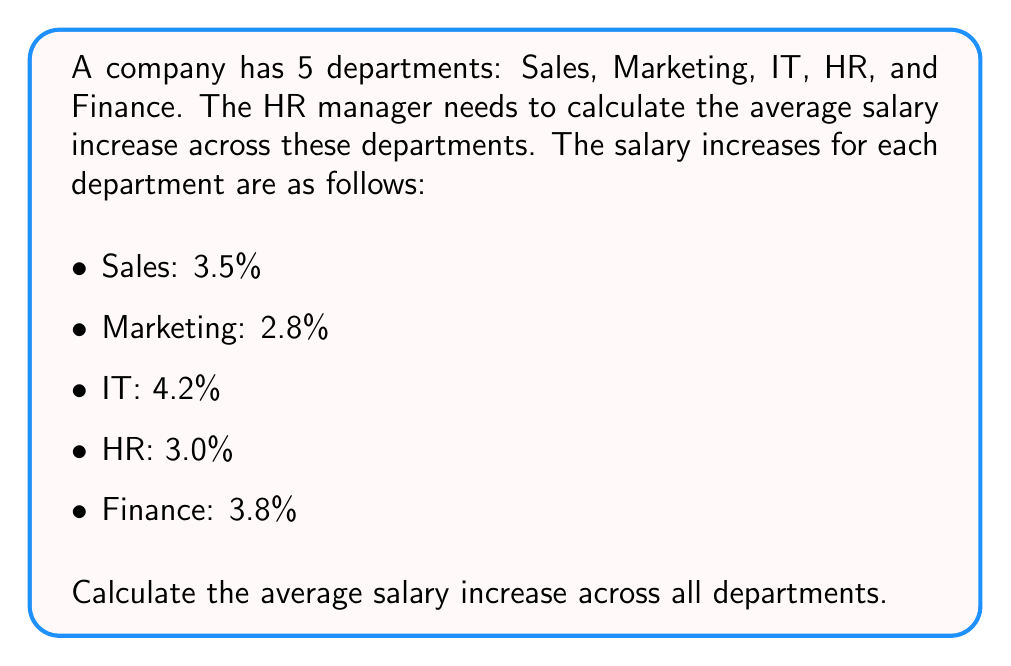Give your solution to this math problem. To calculate the average salary increase across all departments, we need to follow these steps:

1. Sum up all the salary increases:
   $$3.5\% + 2.8\% + 4.2\% + 3.0\% + 3.8\% = 17.3\%$$

2. Count the total number of departments:
   There are 5 departments in total.

3. Calculate the average by dividing the sum by the number of departments:
   $$\text{Average} = \frac{\text{Sum of salary increases}}{\text{Number of departments}}$$
   $$\text{Average} = \frac{17.3\%}{5} = 3.46\%$$

Therefore, the average salary increase across all departments is 3.46%.
Answer: 3.46% 